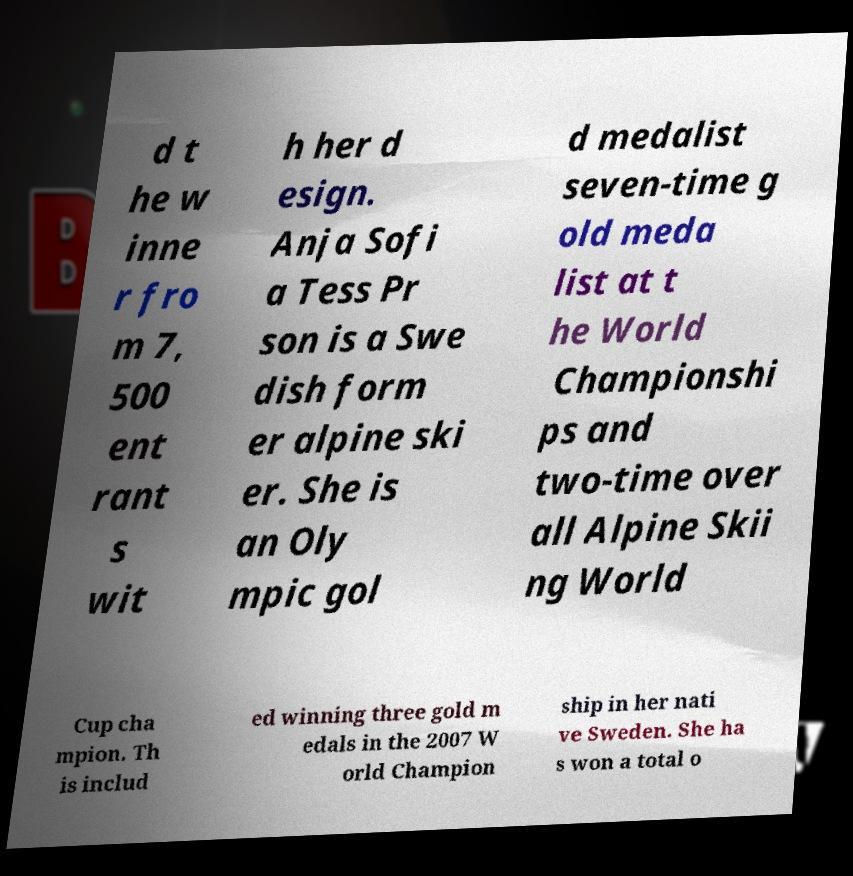What messages or text are displayed in this image? I need them in a readable, typed format. d t he w inne r fro m 7, 500 ent rant s wit h her d esign. Anja Sofi a Tess Pr son is a Swe dish form er alpine ski er. She is an Oly mpic gol d medalist seven-time g old meda list at t he World Championshi ps and two-time over all Alpine Skii ng World Cup cha mpion. Th is includ ed winning three gold m edals in the 2007 W orld Champion ship in her nati ve Sweden. She ha s won a total o 